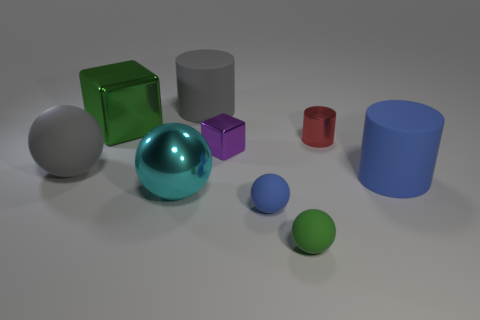What size is the matte thing that is the same color as the large rubber sphere?
Make the answer very short. Large. What number of small green spheres are right of the large ball that is on the right side of the large gray ball?
Your response must be concise. 1. How many balls are both behind the small blue object and right of the big gray sphere?
Provide a succinct answer. 1. How many things are either small red cylinders or balls to the left of the purple metal block?
Provide a succinct answer. 3. What is the size of the purple cube that is the same material as the green block?
Make the answer very short. Small. There is a large shiny thing behind the rubber sphere that is behind the tiny blue rubber object; what is its shape?
Provide a short and direct response. Cube. How many cyan things are either big metallic things or large rubber spheres?
Offer a terse response. 1. Are there any large rubber things behind the large gray thing behind the green thing that is behind the big rubber ball?
Provide a succinct answer. No. There is a large matte object that is the same color as the big rubber ball; what shape is it?
Your answer should be compact. Cylinder. What number of big things are either purple metallic objects or cylinders?
Your answer should be very brief. 2. 